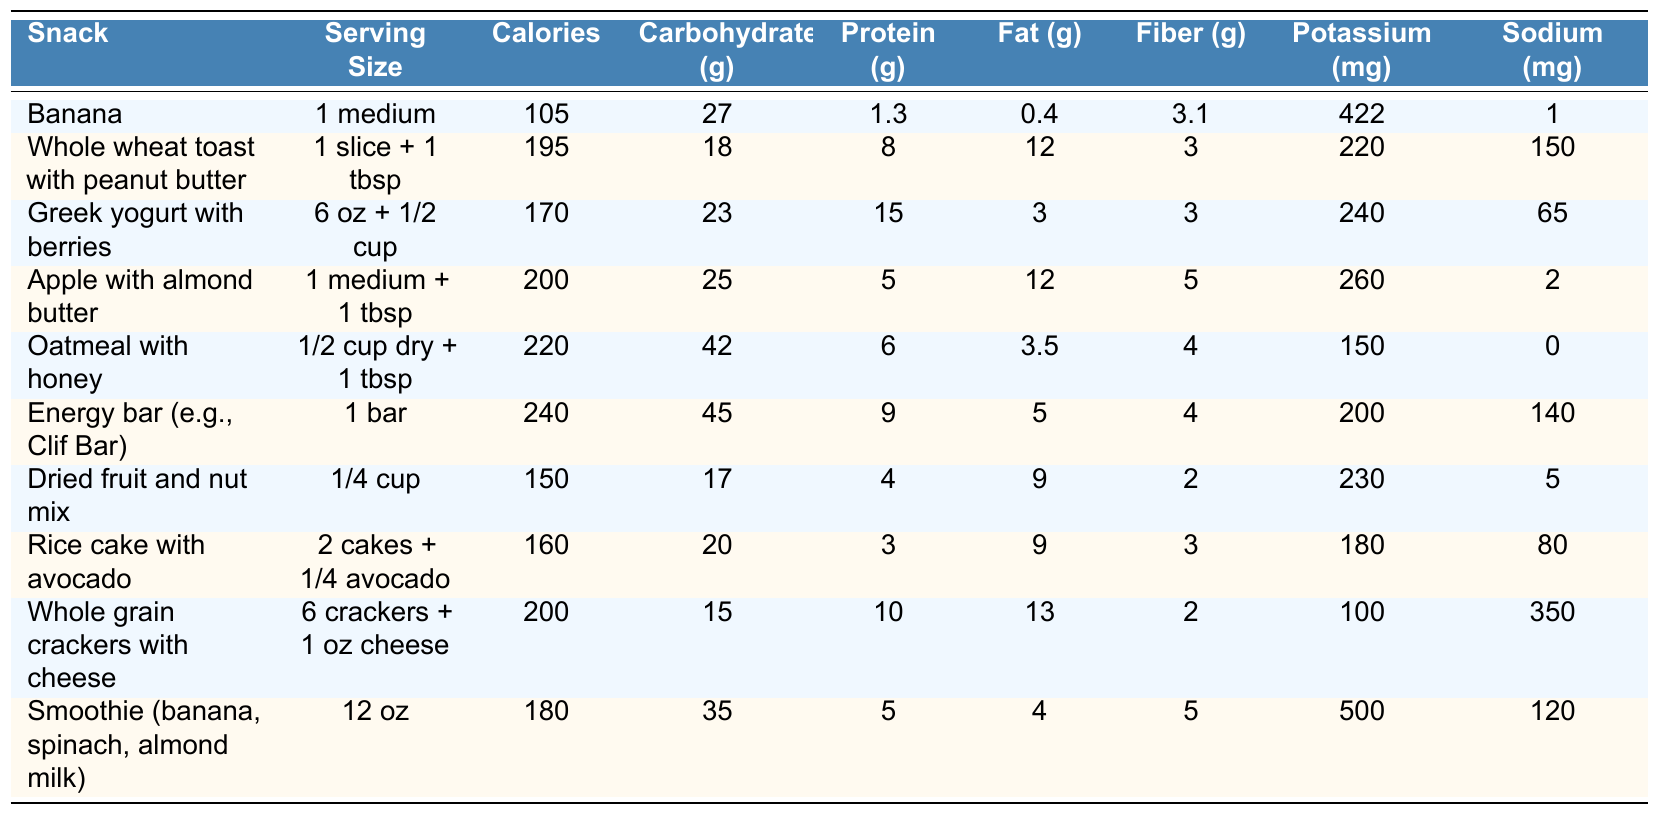What is the calorie content of a banana? The table shows that a medium banana has a calorie content of 105.
Answer: 105 Which snack has the highest protein content? By reviewing the protein content of each snack, Greek yogurt with berries has the highest at 15 grams.
Answer: Greek yogurt with berries What is the total carbohydrate content in an energy bar? The table lists that an energy bar has 45 grams of carbohydrates.
Answer: 45 Is the sodium content in rice cakes with avocado higher than that in oatmeal with honey? Rice cakes with avocado contain 80 mg of sodium, whereas oatmeal with honey has 0 mg. Since 80 is greater than 0, the statement is true.
Answer: Yes What is the average calorie content of the snacks listed? There are 10 snacks in total, and the combined calorie content is 105 + 195 + 170 + 200 + 220 + 240 + 150 + 160 + 200 + 180 = 1870 calories. Dividing that by 10 gives an average of 187 calories.
Answer: 187 How much more fiber does an apple with almond butter have compared to a banana? An apple with almond butter contains 5 grams of fiber, while a banana contains 3. The difference is 5 - 3 = 2 grams.
Answer: 2 grams Which snack has the lowest calorie count? Looking through the table, the snack with the lowest calorie count is a banana, with only 105 calories.
Answer: Banana If someone consumes two servings of whole grain crackers with cheese, how many total calories would they intake? One serving of whole grain crackers with cheese has 200 calories. Therefore, two servings would amount to 200 * 2 = 400 calories.
Answer: 400 What is the total amount of fat in Greek yogurt with berries? The table states that Greek yogurt with berries contains 3 grams of fat.
Answer: 3 grams Is there a snack that contains exactly 200 mg of potassium? Examining the table, it shows that both an apple with almond butter and whole grain crackers with cheese each contain 200 mg of potassium. Therefore, yes, there are snacks with exactly 200 mg of potassium.
Answer: Yes 